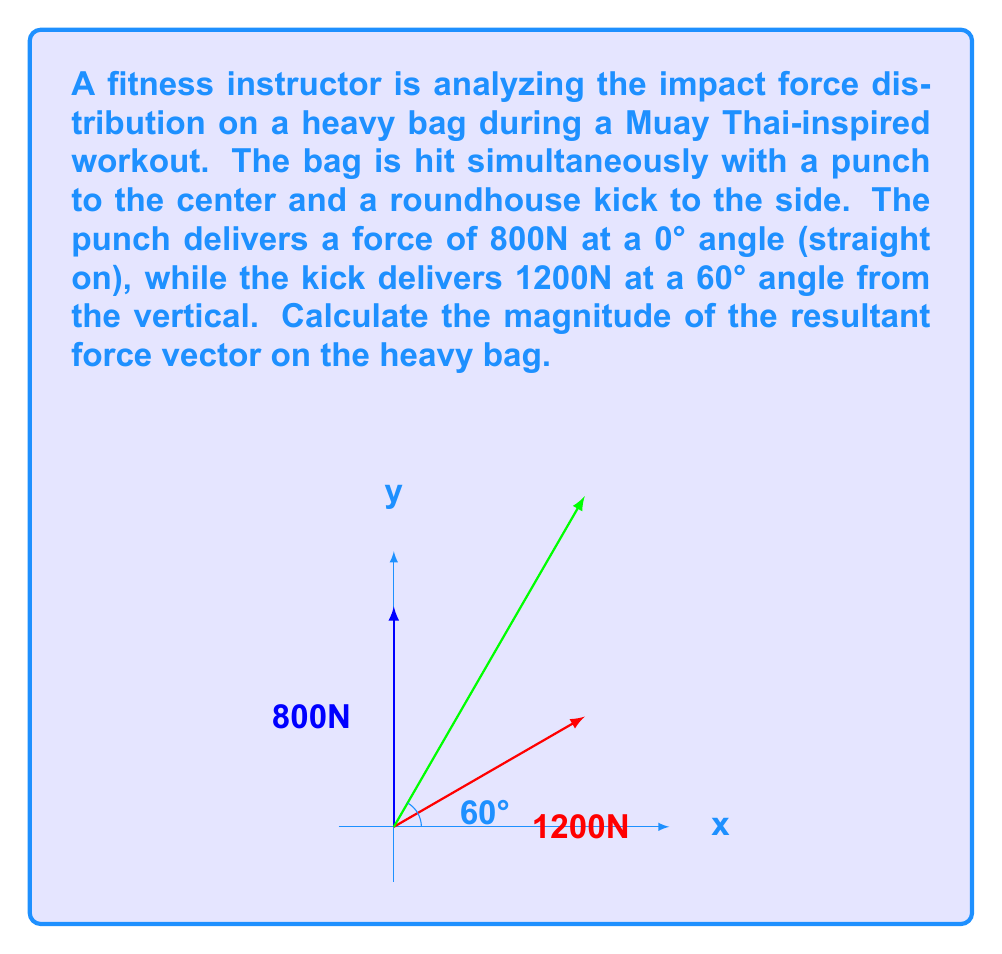Could you help me with this problem? To solve this problem, we'll use vector addition and the Pythagorean theorem. Let's break it down step-by-step:

1) First, let's define our vectors:
   - Punch: $\vec{F_1} = 800\hat{j}$ N (vertical direction)
   - Kick: $\vec{F_2} = 1200(\cos 60°\hat{i} + \sin 60°\hat{j})$ N

2) For the kick vector, we need to calculate its components:
   $\vec{F_2}_x = 1200 \cos 60° = 1200 \cdot 0.5 = 600$ N
   $\vec{F_2}_y = 1200 \sin 60° = 1200 \cdot \frac{\sqrt{3}}{2} = 600\sqrt{3}$ N

3) Now we can add the vectors:
   $\vec{F_{resultant}} = \vec{F_1} + \vec{F_2} = (600\hat{i} + 800\hat{j}) + (600\hat{i} + 600\sqrt{3}\hat{j})$

4) Simplifying:
   $\vec{F_{resultant}} = 1200\hat{i} + (800 + 600\sqrt{3})\hat{j}$

5) To find the magnitude of the resultant vector, we use the Pythagorean theorem:
   $|\vec{F_{resultant}}| = \sqrt{(1200)^2 + (800 + 600\sqrt{3})^2}$

6) Simplifying under the square root:
   $|\vec{F_{resultant}}| = \sqrt{1,440,000 + 640,000 + 960,000\sqrt{3} + 1,080,000}$
   $= \sqrt{3,160,000 + 960,000\sqrt{3}}$

7) Simplifying further:
   $|\vec{F_{resultant}}| = \sqrt{40,000(79 + 24\sqrt{3})}$
   $= 200\sqrt{79 + 24\sqrt{3}}$ N

Therefore, the magnitude of the resultant force vector is $200\sqrt{79 + 24\sqrt{3}}$ N.
Answer: $200\sqrt{79 + 24\sqrt{3}}$ N 